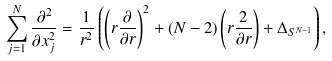Convert formula to latex. <formula><loc_0><loc_0><loc_500><loc_500>\sum _ { j = 1 } ^ { N } \frac { \partial ^ { 2 } } { \partial x _ { j } ^ { 2 } } = \frac { 1 } { r ^ { 2 } } \left ( \left ( r \frac { \partial } { \partial r } \right ) ^ { 2 } + ( N - 2 ) \left ( r \frac { 2 } { \partial r } \right ) + \Delta _ { S ^ { N - 1 } } \right ) ,</formula> 